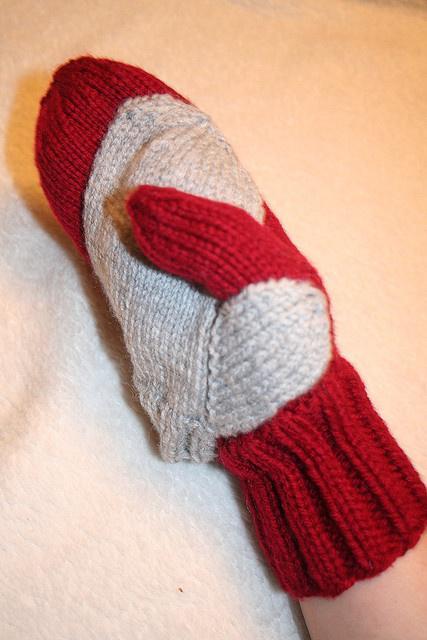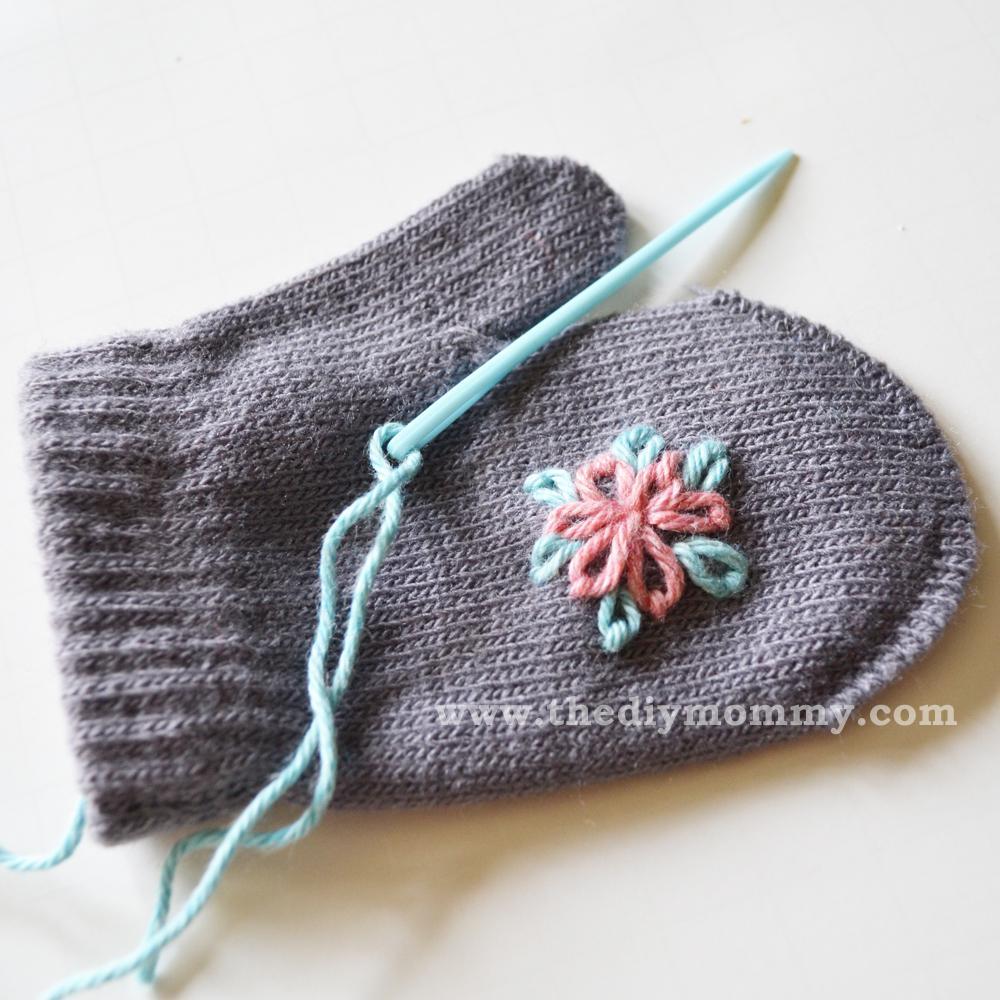The first image is the image on the left, the second image is the image on the right. Considering the images on both sides, is "In one image, a pair of mittens is shown on the cover of a craft book." valid? Answer yes or no. No. 